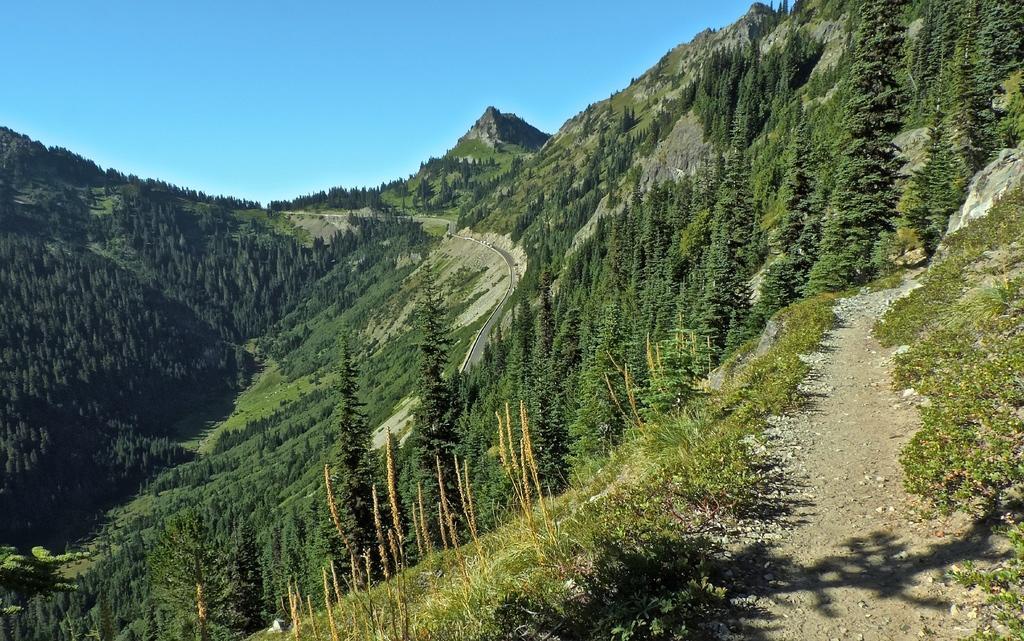Can you describe this image briefly? There are few mountains which are covered with trees on it. 